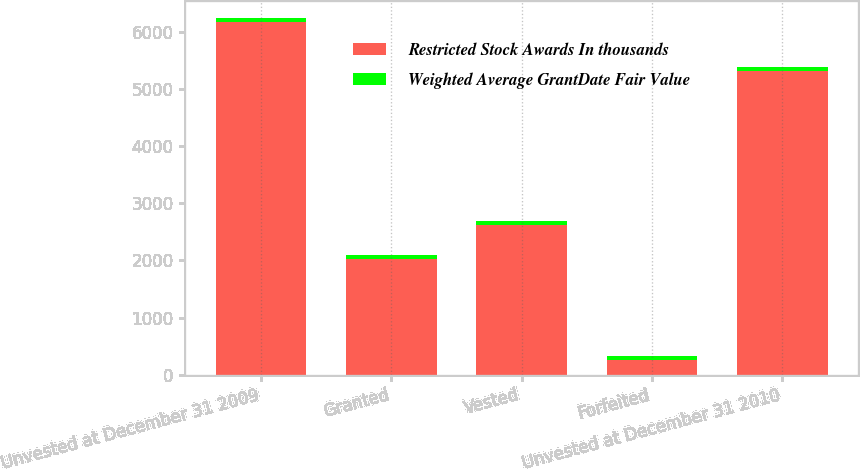Convert chart. <chart><loc_0><loc_0><loc_500><loc_500><stacked_bar_chart><ecel><fcel>Unvested at December 31 2009<fcel>Granted<fcel>Vested<fcel>Forfeited<fcel>Unvested at December 31 2010<nl><fcel>Restricted Stock Awards In thousands<fcel>6165<fcel>2026<fcel>2619<fcel>261<fcel>5311<nl><fcel>Weighted Average GrantDate Fair Value<fcel>69.76<fcel>73.19<fcel>70.56<fcel>70.94<fcel>70.6<nl></chart> 